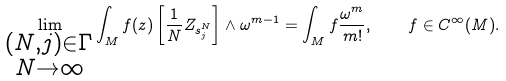<formula> <loc_0><loc_0><loc_500><loc_500>\lim _ { \substack { ( N , j ) \in \Gamma \\ N \rightarrow \infty } } \int _ { M } f ( z ) \left [ \frac { 1 } { N } Z _ { s _ { j } ^ { N } } \right ] \wedge \omega ^ { m - 1 } = \int _ { M } f \frac { \omega ^ { m } } { m ! } , \quad f \in C ^ { \infty } ( M ) .</formula> 